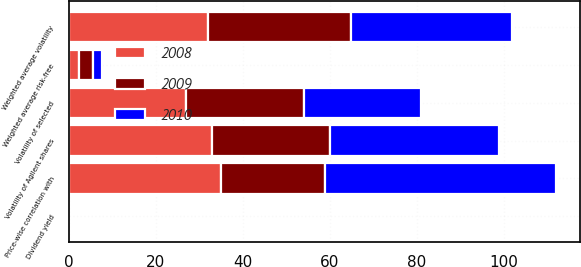<chart> <loc_0><loc_0><loc_500><loc_500><stacked_bar_chart><ecel><fcel>Weighted average risk-free<fcel>Dividend yield<fcel>Weighted average volatility<fcel>Volatility of Agilent shares<fcel>Volatility of selected<fcel>Price-wise correlation with<nl><fcel>2010<fcel>2.19<fcel>0<fcel>37<fcel>39<fcel>27<fcel>53<nl><fcel>2008<fcel>2.31<fcel>0<fcel>32<fcel>33<fcel>27<fcel>35<nl><fcel>2009<fcel>3.16<fcel>0<fcel>33<fcel>27<fcel>27<fcel>24<nl></chart> 